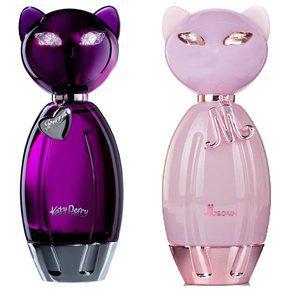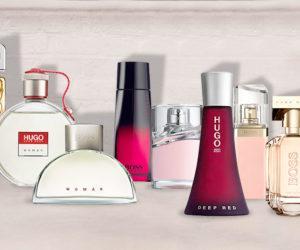The first image is the image on the left, the second image is the image on the right. Assess this claim about the two images: "One image includes a fragrance bottle with a shape inspired by some type of animal.". Correct or not? Answer yes or no. Yes. The first image is the image on the left, the second image is the image on the right. Considering the images on both sides, is "The left image contains only two fragrance-related objects, which are side-by-side but not touching and include a lavender bottle with a metallic element." valid? Answer yes or no. Yes. The first image is the image on the left, the second image is the image on the right. Analyze the images presented: Is the assertion "There is a single vial near its box in one of the images." valid? Answer yes or no. No. 